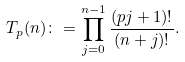<formula> <loc_0><loc_0><loc_500><loc_500>T _ { p } ( n ) \colon = \prod _ { j = 0 } ^ { n - 1 } \frac { ( p j + 1 ) ! } { ( n + j ) ! } .</formula> 